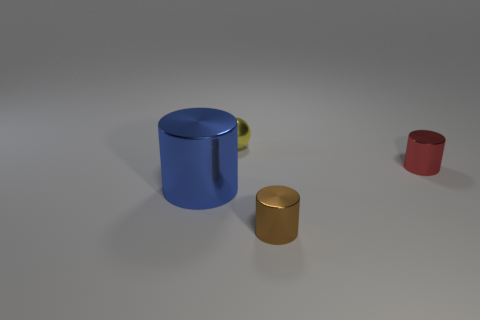Add 1 red cylinders. How many objects exist? 5 Subtract all cylinders. How many objects are left? 1 Add 2 large brown cylinders. How many large brown cylinders exist? 2 Subtract 0 green balls. How many objects are left? 4 Subtract all small green spheres. Subtract all metallic balls. How many objects are left? 3 Add 1 large metallic cylinders. How many large metallic cylinders are left? 2 